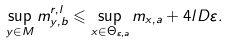<formula> <loc_0><loc_0><loc_500><loc_500>\sup _ { y \in M } m _ { y , b } ^ { r , l } \leqslant \sup _ { x \in \Theta _ { \varepsilon , a } } m _ { x , a } + 4 l D \varepsilon .</formula> 